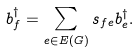Convert formula to latex. <formula><loc_0><loc_0><loc_500><loc_500>b ^ { \dagger } _ { f } = \sum _ { e \in E ( G ) } s _ { f e } b ^ { \dagger } _ { e } .</formula> 